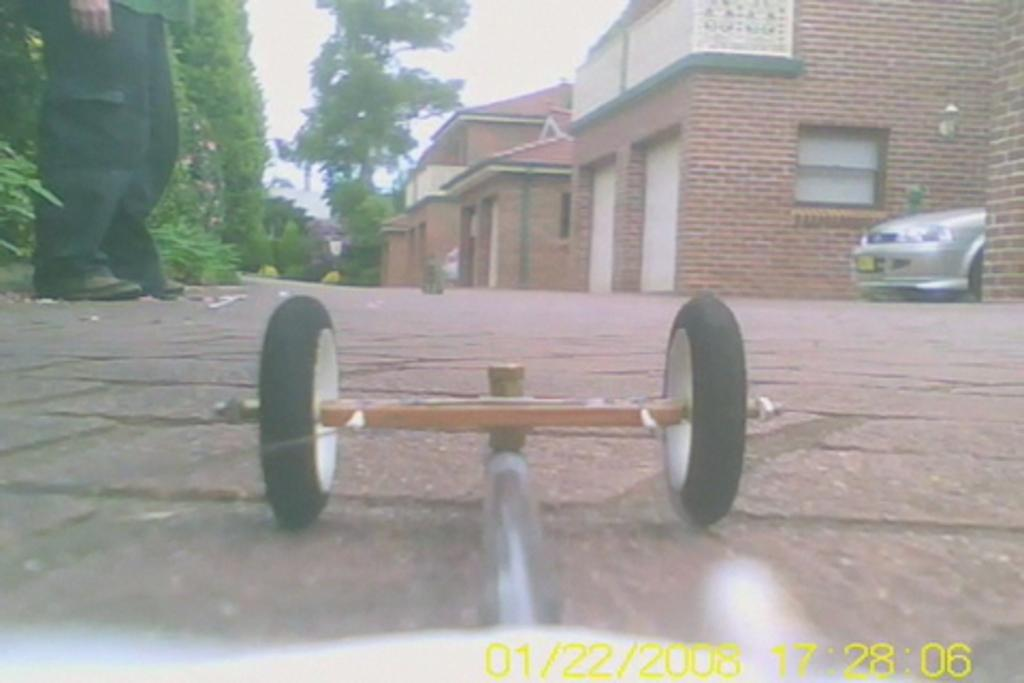What is the main subject of the image? There is a mini car on a path in the image. Can you describe the man in the image? There is a man standing in the top left corner of the image. What type of natural elements can be seen in the image? There are trees in the image. What can be seen in the background of the image? There are houses and a car in the background of the image. What type of letters are being read by the mini car in the image? There are no letters being read by the mini car in the image, as it is a toy car and not capable of reading. How many books can be seen on the path next to the mini car? There are no books present on the path next to the mini car in the image. 